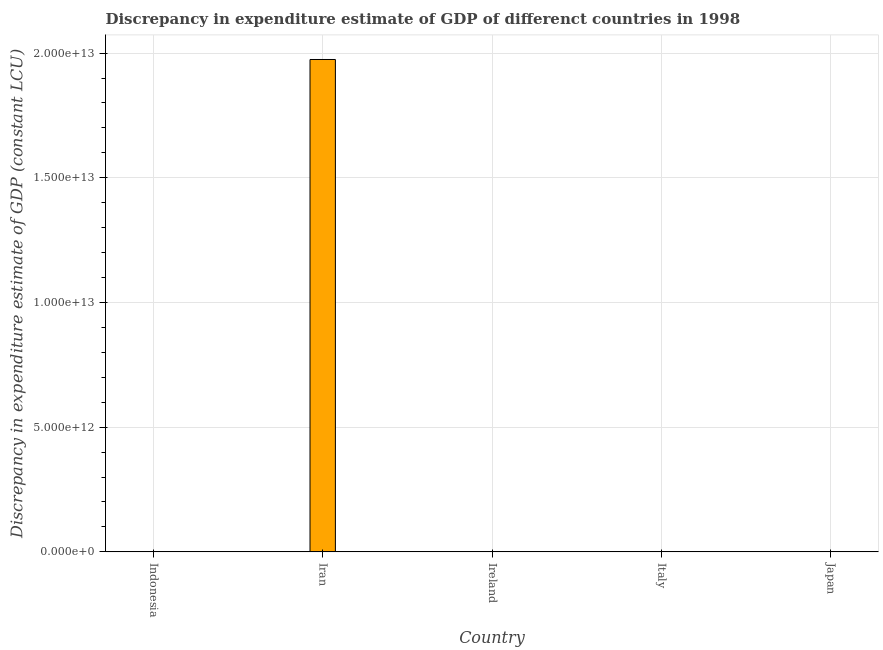Does the graph contain any zero values?
Your answer should be compact. Yes. What is the title of the graph?
Your answer should be compact. Discrepancy in expenditure estimate of GDP of differenct countries in 1998. What is the label or title of the X-axis?
Provide a short and direct response. Country. What is the label or title of the Y-axis?
Make the answer very short. Discrepancy in expenditure estimate of GDP (constant LCU). What is the discrepancy in expenditure estimate of gdp in Italy?
Offer a terse response. 0. Across all countries, what is the maximum discrepancy in expenditure estimate of gdp?
Make the answer very short. 1.97e+13. Across all countries, what is the minimum discrepancy in expenditure estimate of gdp?
Keep it short and to the point. 0. In which country was the discrepancy in expenditure estimate of gdp maximum?
Your answer should be very brief. Iran. What is the sum of the discrepancy in expenditure estimate of gdp?
Offer a terse response. 1.97e+13. What is the difference between the discrepancy in expenditure estimate of gdp in Iran and Ireland?
Offer a terse response. 1.97e+13. What is the average discrepancy in expenditure estimate of gdp per country?
Offer a very short reply. 3.95e+12. What is the ratio of the discrepancy in expenditure estimate of gdp in Iran to that in Ireland?
Provide a short and direct response. 1.59e+04. What is the difference between the highest and the lowest discrepancy in expenditure estimate of gdp?
Provide a succinct answer. 1.97e+13. How many bars are there?
Keep it short and to the point. 2. What is the difference between two consecutive major ticks on the Y-axis?
Provide a short and direct response. 5.00e+12. What is the Discrepancy in expenditure estimate of GDP (constant LCU) of Indonesia?
Offer a very short reply. 0. What is the Discrepancy in expenditure estimate of GDP (constant LCU) in Iran?
Offer a very short reply. 1.97e+13. What is the Discrepancy in expenditure estimate of GDP (constant LCU) of Ireland?
Your answer should be very brief. 1.24e+09. What is the difference between the Discrepancy in expenditure estimate of GDP (constant LCU) in Iran and Ireland?
Offer a terse response. 1.97e+13. What is the ratio of the Discrepancy in expenditure estimate of GDP (constant LCU) in Iran to that in Ireland?
Your answer should be very brief. 1.59e+04. 